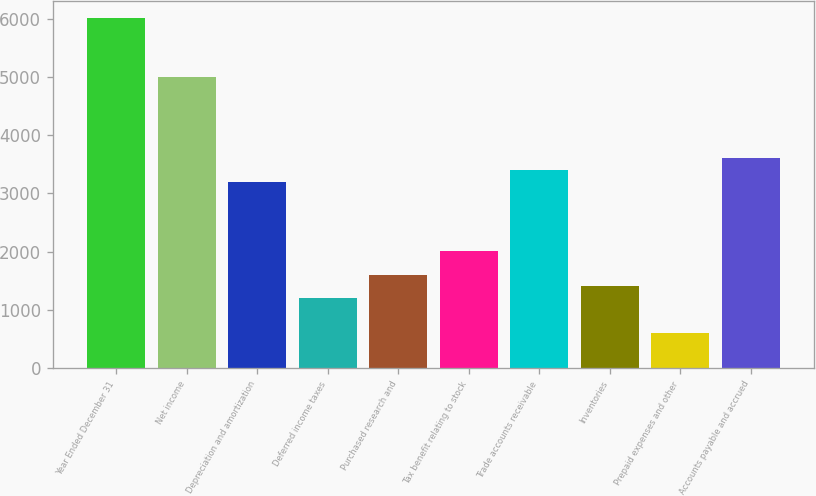Convert chart. <chart><loc_0><loc_0><loc_500><loc_500><bar_chart><fcel>Year Ended December 31<fcel>Net income<fcel>Depreciation and amortization<fcel>Deferred income taxes<fcel>Purchased research and<fcel>Tax benefit relating to stock<fcel>Trade accounts receivable<fcel>Inventories<fcel>Prepaid expenses and other<fcel>Accounts payable and accrued<nl><fcel>6008<fcel>5007<fcel>3205.2<fcel>1203.2<fcel>1603.6<fcel>2004<fcel>3405.4<fcel>1403.4<fcel>602.6<fcel>3605.6<nl></chart> 